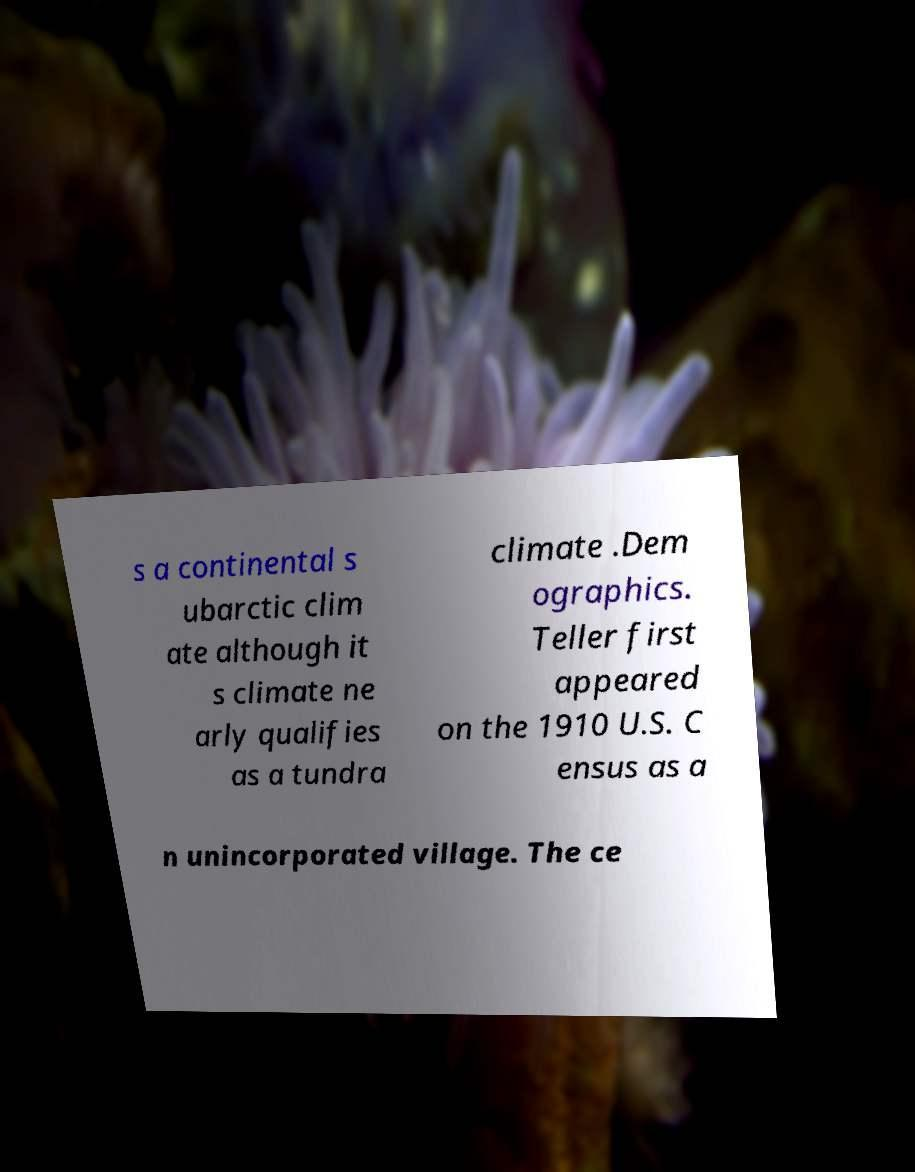There's text embedded in this image that I need extracted. Can you transcribe it verbatim? s a continental s ubarctic clim ate although it s climate ne arly qualifies as a tundra climate .Dem ographics. Teller first appeared on the 1910 U.S. C ensus as a n unincorporated village. The ce 